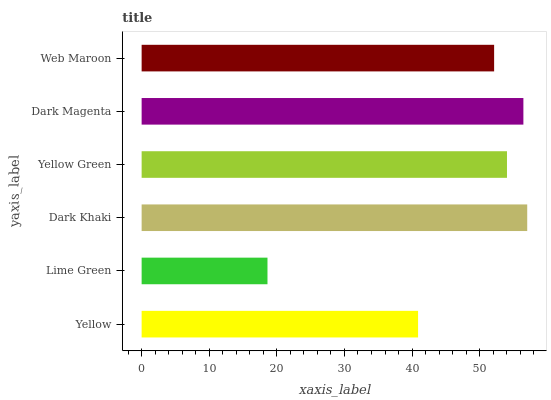Is Lime Green the minimum?
Answer yes or no. Yes. Is Dark Khaki the maximum?
Answer yes or no. Yes. Is Dark Khaki the minimum?
Answer yes or no. No. Is Lime Green the maximum?
Answer yes or no. No. Is Dark Khaki greater than Lime Green?
Answer yes or no. Yes. Is Lime Green less than Dark Khaki?
Answer yes or no. Yes. Is Lime Green greater than Dark Khaki?
Answer yes or no. No. Is Dark Khaki less than Lime Green?
Answer yes or no. No. Is Yellow Green the high median?
Answer yes or no. Yes. Is Web Maroon the low median?
Answer yes or no. Yes. Is Dark Magenta the high median?
Answer yes or no. No. Is Dark Magenta the low median?
Answer yes or no. No. 